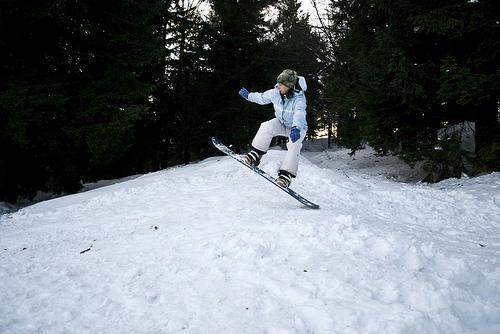How many people are in the photo?
Give a very brief answer. 1. 